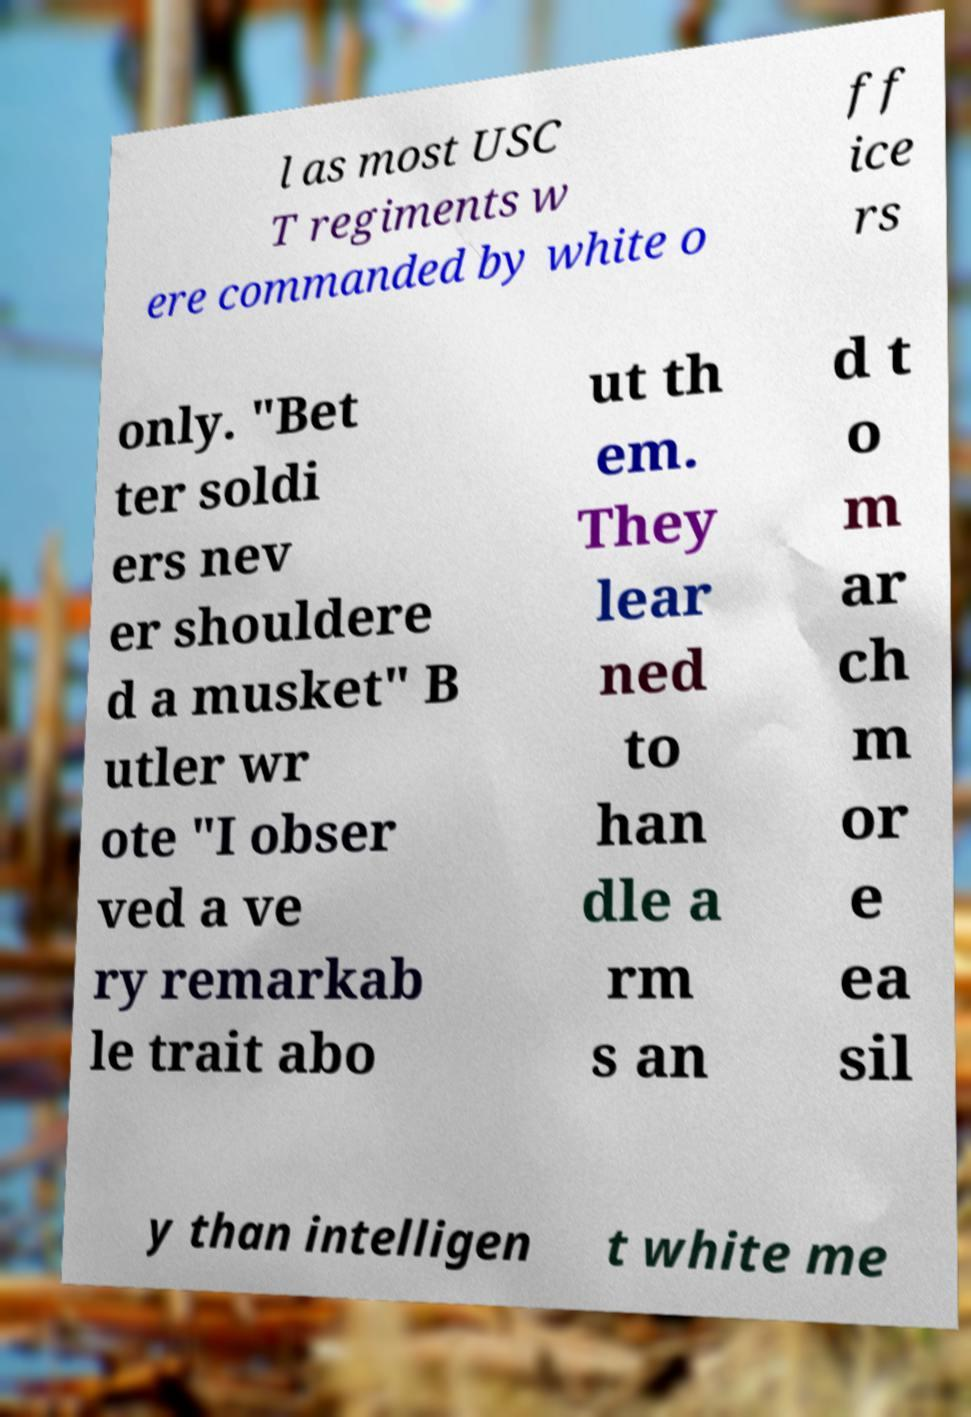Please identify and transcribe the text found in this image. l as most USC T regiments w ere commanded by white o ff ice rs only. "Bet ter soldi ers nev er shouldere d a musket" B utler wr ote "I obser ved a ve ry remarkab le trait abo ut th em. They lear ned to han dle a rm s an d t o m ar ch m or e ea sil y than intelligen t white me 